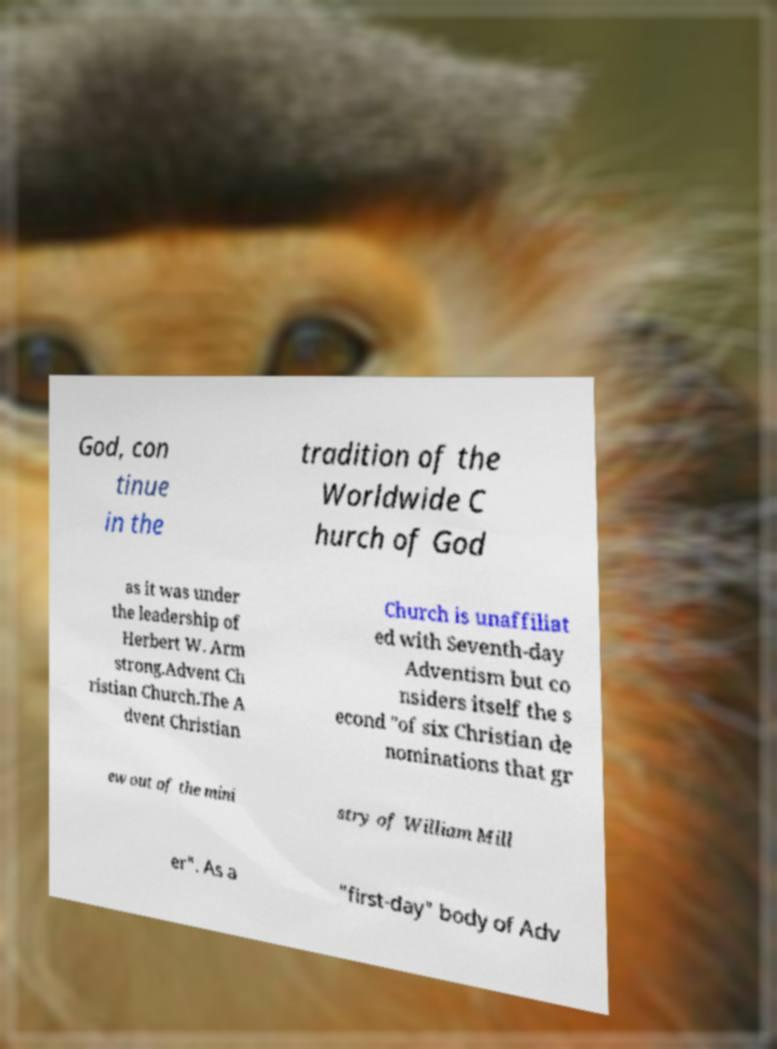I need the written content from this picture converted into text. Can you do that? God, con tinue in the tradition of the Worldwide C hurch of God as it was under the leadership of Herbert W. Arm strong.Advent Ch ristian Church.The A dvent Christian Church is unaffiliat ed with Seventh-day Adventism but co nsiders itself the s econd "of six Christian de nominations that gr ew out of the mini stry of William Mill er". As a "first-day" body of Adv 